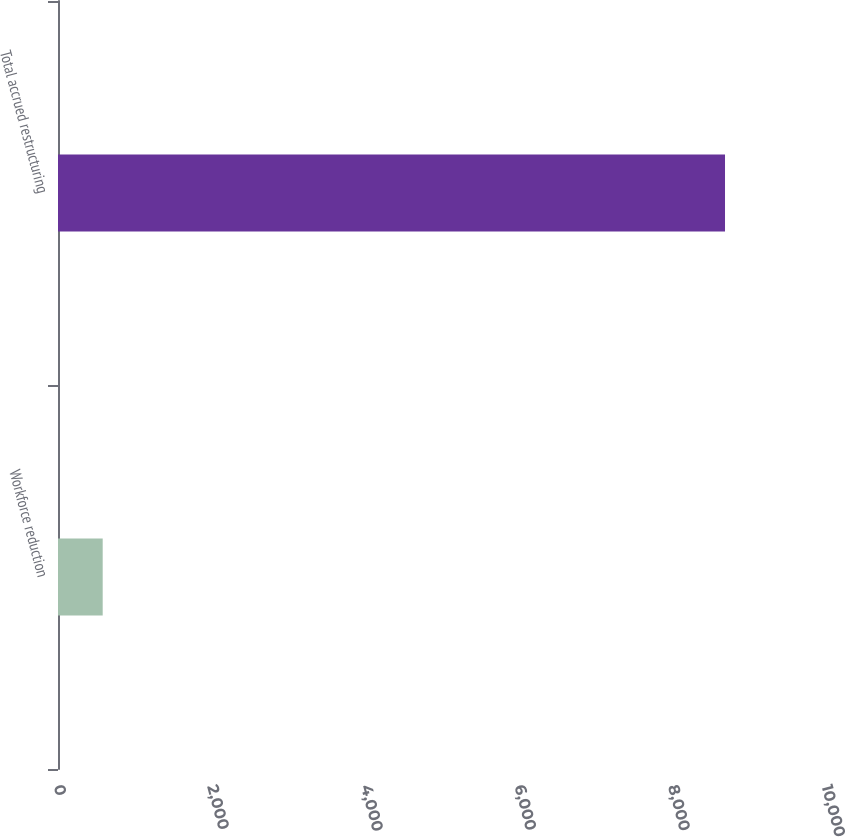<chart> <loc_0><loc_0><loc_500><loc_500><bar_chart><fcel>Workforce reduction<fcel>Total accrued restructuring<nl><fcel>582<fcel>8685<nl></chart> 